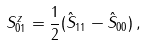<formula> <loc_0><loc_0><loc_500><loc_500>S _ { 0 1 } ^ { z } = \frac { 1 } { 2 } ( \hat { S } _ { 1 1 } - \hat { S } _ { 0 0 } ) \, ,</formula> 